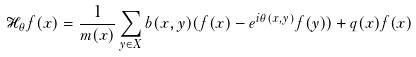<formula> <loc_0><loc_0><loc_500><loc_500>\mathcal { H } _ { \theta } f ( x ) = \frac { 1 } { m ( x ) } \sum _ { y \in X } b ( x , y ) ( f ( x ) - e ^ { i \theta ( x , y ) } f ( y ) ) + q ( x ) f ( x )</formula> 